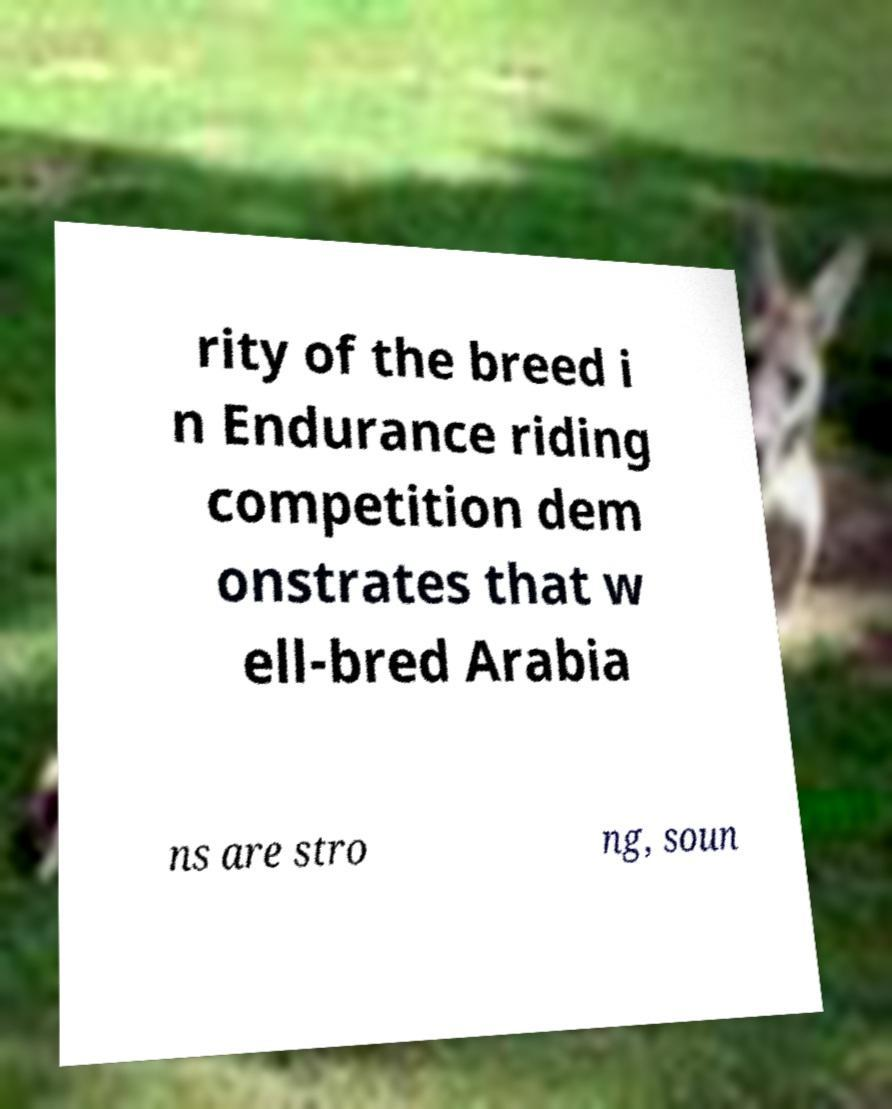What messages or text are displayed in this image? I need them in a readable, typed format. rity of the breed i n Endurance riding competition dem onstrates that w ell-bred Arabia ns are stro ng, soun 